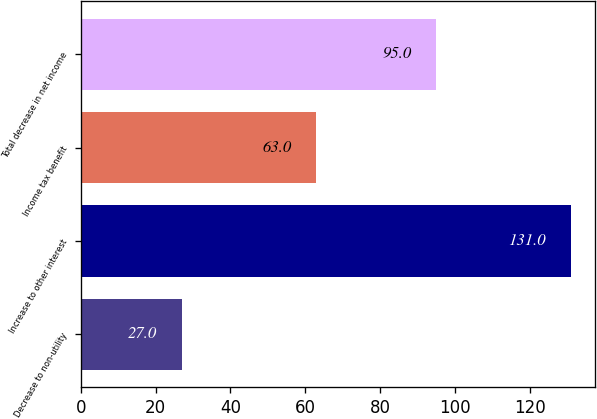Convert chart to OTSL. <chart><loc_0><loc_0><loc_500><loc_500><bar_chart><fcel>Decrease to non-utility<fcel>Increase to other interest<fcel>Income tax benefit<fcel>Total decrease in net income<nl><fcel>27<fcel>131<fcel>63<fcel>95<nl></chart> 